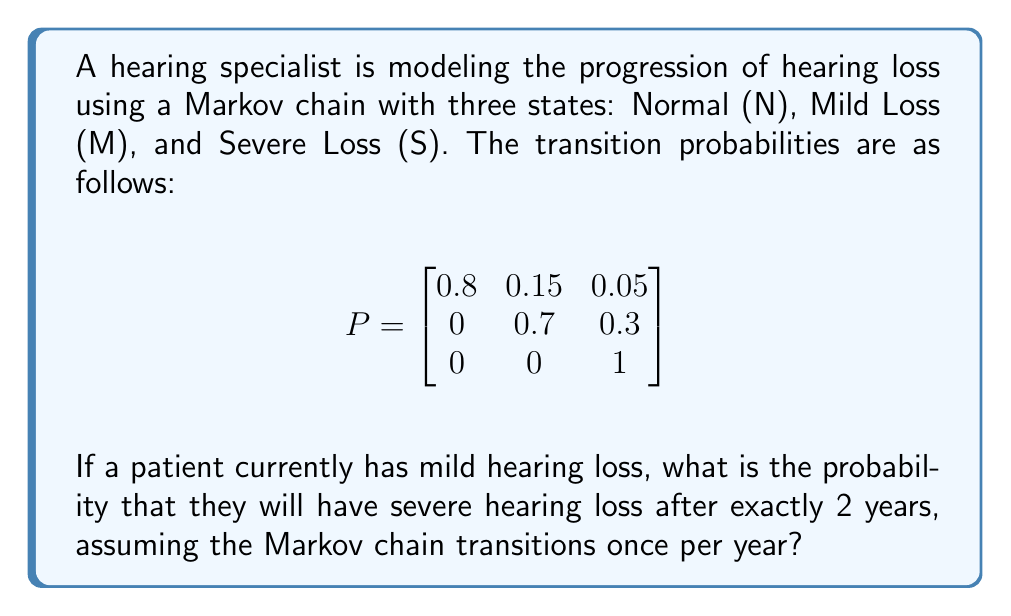Show me your answer to this math problem. To solve this problem, we need to follow these steps:

1) First, we identify the initial state and the target state:
   - Initial state: Mild Loss (M)
   - Target state after 2 years: Severe Loss (S)

2) We need to calculate $P^2$ (the transition matrix raised to the power of 2) because we're interested in the state after 2 transitions.

3) To calculate $P^2$, we multiply P by itself:

   $$
   P^2 = \begin{bmatrix}
   0.8 & 0.15 & 0.05 \\
   0 & 0.7 & 0.3 \\
   0 & 0 & 1
   \end{bmatrix} \times 
   \begin{bmatrix}
   0.8 & 0.15 & 0.05 \\
   0 & 0.7 & 0.3 \\
   0 & 0 & 1
   \end{bmatrix}
   $$

4) After multiplication, we get:

   $$
   P^2 = \begin{bmatrix}
   0.64 & 0.225 & 0.135 \\
   0 & 0.49 & 0.51 \\
   0 & 0 & 1
   \end{bmatrix}
   $$

5) The probability we're looking for is the entry in the 2nd row (Mild Loss) and 3rd column (Severe Loss) of $P^2$.

6) This probability is 0.51 or 51%.
Answer: 0.51 